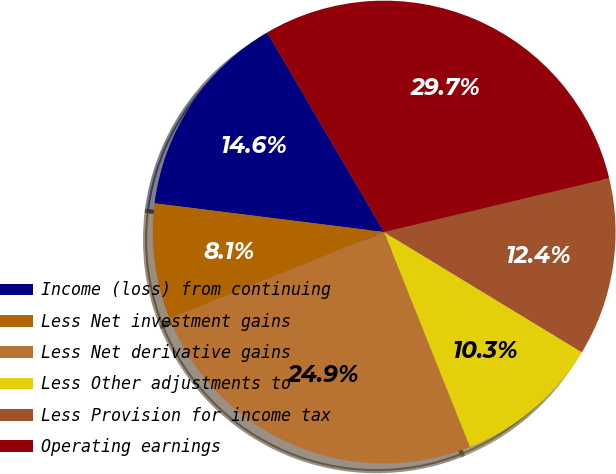Convert chart. <chart><loc_0><loc_0><loc_500><loc_500><pie_chart><fcel>Income (loss) from continuing<fcel>Less Net investment gains<fcel>Less Net derivative gains<fcel>Less Other adjustments to<fcel>Less Provision for income tax<fcel>Operating earnings<nl><fcel>14.58%<fcel>8.09%<fcel>24.94%<fcel>10.26%<fcel>12.42%<fcel>29.7%<nl></chart> 